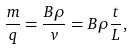<formula> <loc_0><loc_0><loc_500><loc_500>\frac { m } { q } = \frac { B \rho } { v } = B \rho \frac { t } { L } ,</formula> 